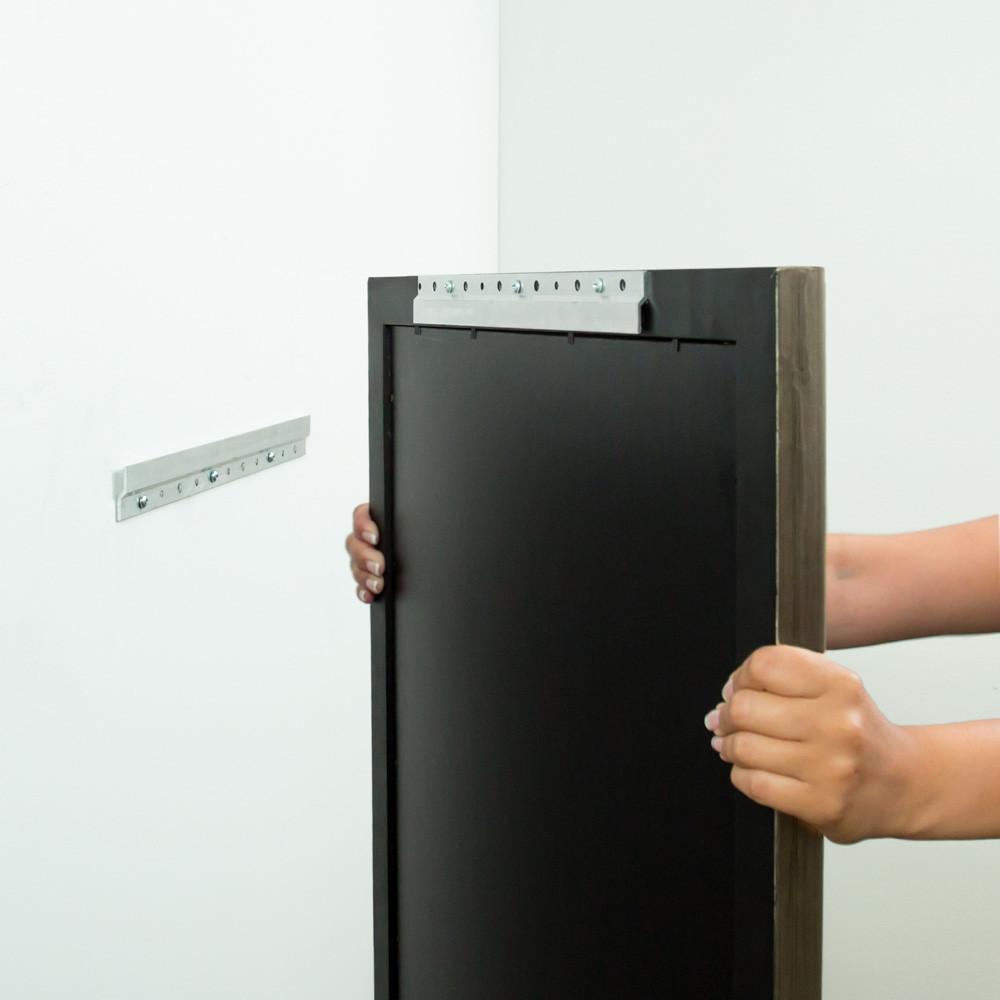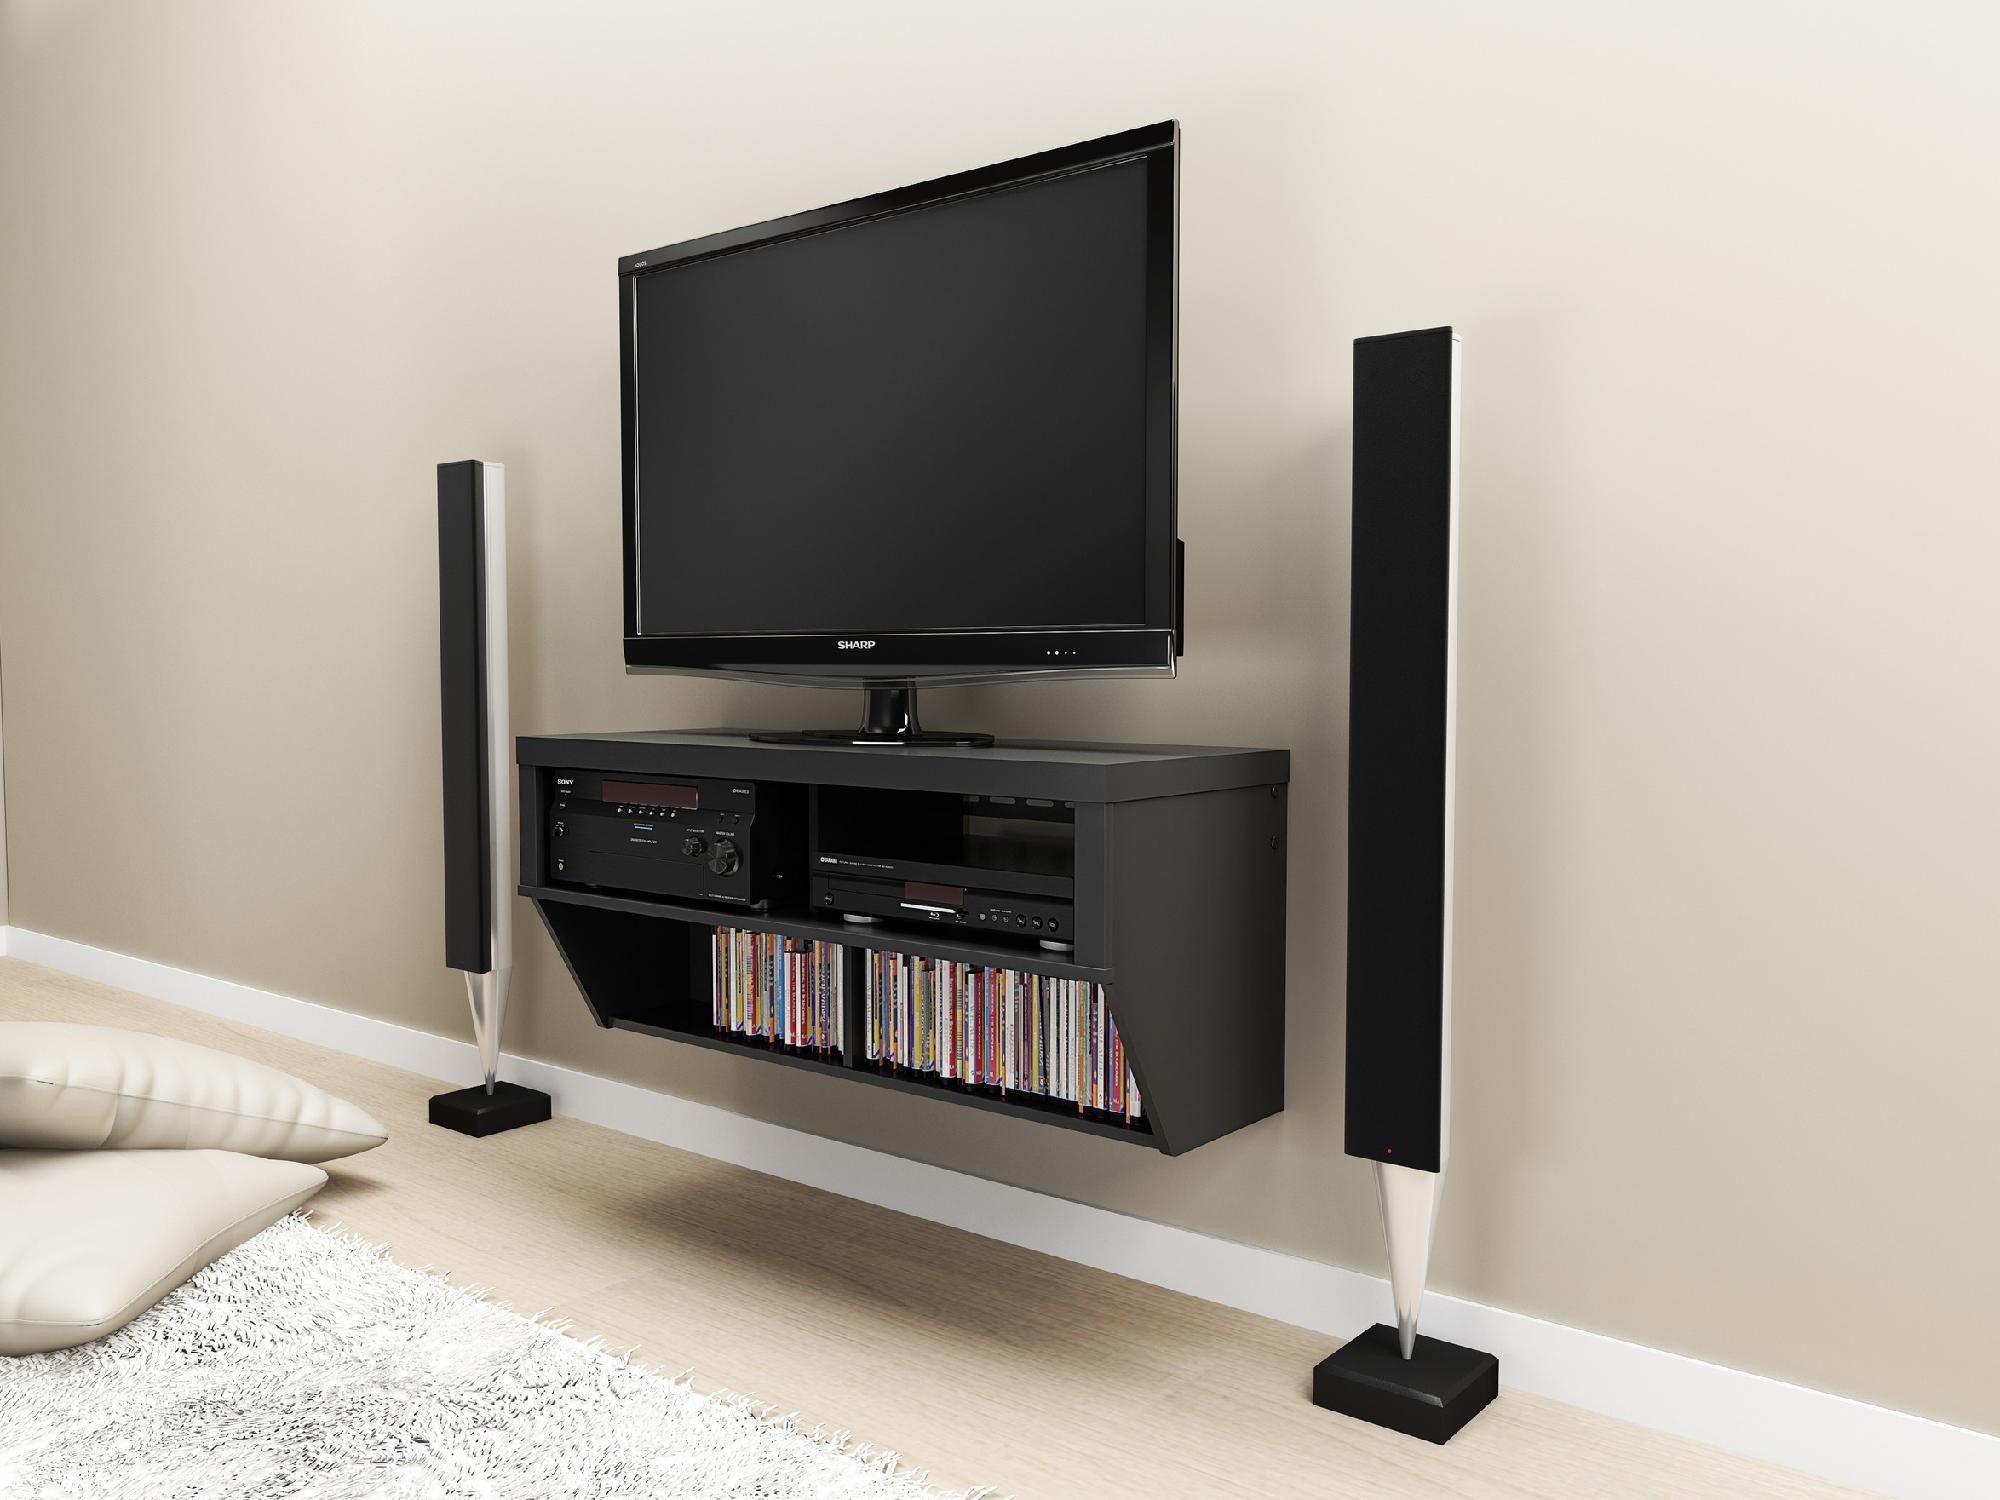The first image is the image on the left, the second image is the image on the right. Evaluate the accuracy of this statement regarding the images: "In the left image a television is attached to the wall.". Is it true? Answer yes or no. No. The first image is the image on the left, the second image is the image on the right. Assess this claim about the two images: "The right image shows a side-view of a TV on a pivoting wall-mounted arm, and the left image shows a TV screen above a narrow shelf.". Correct or not? Answer yes or no. No. 